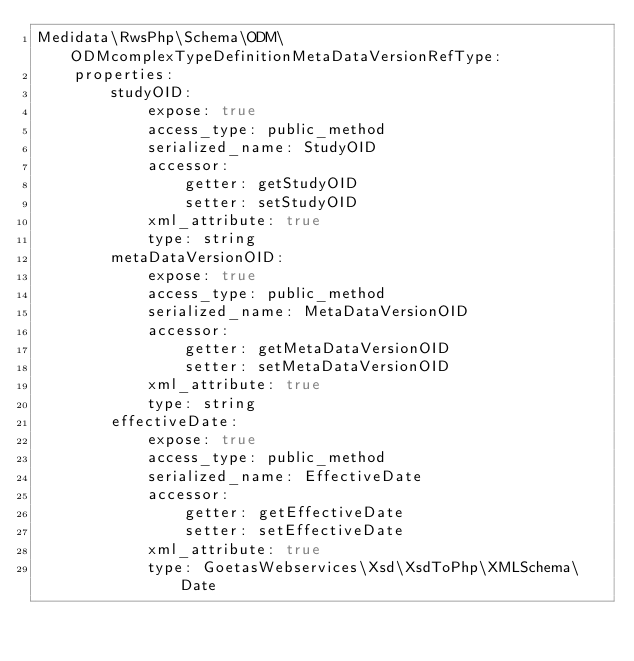Convert code to text. <code><loc_0><loc_0><loc_500><loc_500><_YAML_>Medidata\RwsPhp\Schema\ODM\ODMcomplexTypeDefinitionMetaDataVersionRefType:
    properties:
        studyOID:
            expose: true
            access_type: public_method
            serialized_name: StudyOID
            accessor:
                getter: getStudyOID
                setter: setStudyOID
            xml_attribute: true
            type: string
        metaDataVersionOID:
            expose: true
            access_type: public_method
            serialized_name: MetaDataVersionOID
            accessor:
                getter: getMetaDataVersionOID
                setter: setMetaDataVersionOID
            xml_attribute: true
            type: string
        effectiveDate:
            expose: true
            access_type: public_method
            serialized_name: EffectiveDate
            accessor:
                getter: getEffectiveDate
                setter: setEffectiveDate
            xml_attribute: true
            type: GoetasWebservices\Xsd\XsdToPhp\XMLSchema\Date
</code> 